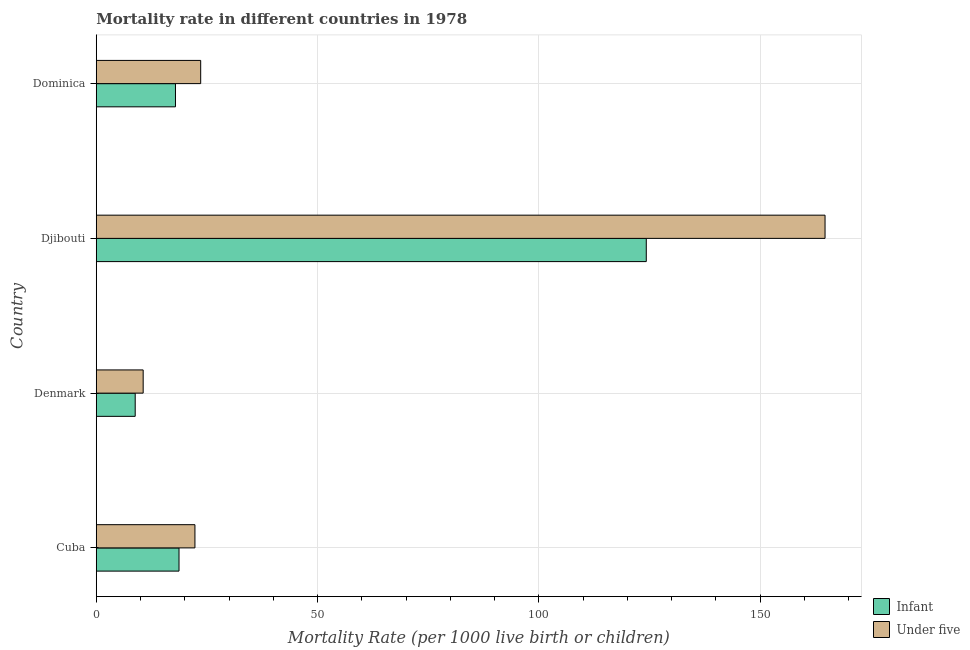Are the number of bars per tick equal to the number of legend labels?
Your response must be concise. Yes. Are the number of bars on each tick of the Y-axis equal?
Your response must be concise. Yes. How many bars are there on the 2nd tick from the top?
Provide a short and direct response. 2. What is the label of the 3rd group of bars from the top?
Offer a terse response. Denmark. What is the infant mortality rate in Denmark?
Your answer should be compact. 8.8. Across all countries, what is the maximum infant mortality rate?
Ensure brevity in your answer.  124.3. In which country was the under-5 mortality rate maximum?
Your response must be concise. Djibouti. In which country was the infant mortality rate minimum?
Your response must be concise. Denmark. What is the total under-5 mortality rate in the graph?
Provide a succinct answer. 221.2. What is the difference between the infant mortality rate in Denmark and that in Djibouti?
Ensure brevity in your answer.  -115.5. What is the difference between the under-5 mortality rate in Cuba and the infant mortality rate in Dominica?
Make the answer very short. 4.4. What is the average infant mortality rate per country?
Make the answer very short. 42.42. What is the difference between the under-5 mortality rate and infant mortality rate in Cuba?
Keep it short and to the point. 3.6. In how many countries, is the infant mortality rate greater than 140 ?
Ensure brevity in your answer.  0. What is the ratio of the infant mortality rate in Denmark to that in Djibouti?
Provide a short and direct response. 0.07. What is the difference between the highest and the second highest infant mortality rate?
Offer a terse response. 105.6. What is the difference between the highest and the lowest under-5 mortality rate?
Provide a short and direct response. 154.1. In how many countries, is the under-5 mortality rate greater than the average under-5 mortality rate taken over all countries?
Offer a terse response. 1. Is the sum of the under-5 mortality rate in Cuba and Dominica greater than the maximum infant mortality rate across all countries?
Give a very brief answer. No. What does the 2nd bar from the top in Cuba represents?
Offer a very short reply. Infant. What does the 2nd bar from the bottom in Djibouti represents?
Offer a very short reply. Under five. How many bars are there?
Make the answer very short. 8. How many countries are there in the graph?
Provide a short and direct response. 4. Are the values on the major ticks of X-axis written in scientific E-notation?
Offer a terse response. No. Does the graph contain any zero values?
Offer a very short reply. No. Does the graph contain grids?
Your response must be concise. Yes. Where does the legend appear in the graph?
Offer a very short reply. Bottom right. How many legend labels are there?
Ensure brevity in your answer.  2. How are the legend labels stacked?
Your answer should be very brief. Vertical. What is the title of the graph?
Offer a very short reply. Mortality rate in different countries in 1978. Does "Merchandise imports" appear as one of the legend labels in the graph?
Provide a short and direct response. No. What is the label or title of the X-axis?
Keep it short and to the point. Mortality Rate (per 1000 live birth or children). What is the label or title of the Y-axis?
Keep it short and to the point. Country. What is the Mortality Rate (per 1000 live birth or children) of Under five in Cuba?
Your answer should be very brief. 22.3. What is the Mortality Rate (per 1000 live birth or children) of Infant in Djibouti?
Give a very brief answer. 124.3. What is the Mortality Rate (per 1000 live birth or children) in Under five in Djibouti?
Your answer should be very brief. 164.7. What is the Mortality Rate (per 1000 live birth or children) in Under five in Dominica?
Your answer should be compact. 23.6. Across all countries, what is the maximum Mortality Rate (per 1000 live birth or children) in Infant?
Offer a very short reply. 124.3. Across all countries, what is the maximum Mortality Rate (per 1000 live birth or children) of Under five?
Provide a succinct answer. 164.7. Across all countries, what is the minimum Mortality Rate (per 1000 live birth or children) in Infant?
Give a very brief answer. 8.8. What is the total Mortality Rate (per 1000 live birth or children) in Infant in the graph?
Your answer should be compact. 169.7. What is the total Mortality Rate (per 1000 live birth or children) in Under five in the graph?
Your answer should be very brief. 221.2. What is the difference between the Mortality Rate (per 1000 live birth or children) in Infant in Cuba and that in Denmark?
Give a very brief answer. 9.9. What is the difference between the Mortality Rate (per 1000 live birth or children) of Infant in Cuba and that in Djibouti?
Give a very brief answer. -105.6. What is the difference between the Mortality Rate (per 1000 live birth or children) in Under five in Cuba and that in Djibouti?
Provide a succinct answer. -142.4. What is the difference between the Mortality Rate (per 1000 live birth or children) in Infant in Cuba and that in Dominica?
Give a very brief answer. 0.8. What is the difference between the Mortality Rate (per 1000 live birth or children) of Under five in Cuba and that in Dominica?
Offer a terse response. -1.3. What is the difference between the Mortality Rate (per 1000 live birth or children) of Infant in Denmark and that in Djibouti?
Keep it short and to the point. -115.5. What is the difference between the Mortality Rate (per 1000 live birth or children) in Under five in Denmark and that in Djibouti?
Provide a succinct answer. -154.1. What is the difference between the Mortality Rate (per 1000 live birth or children) of Infant in Denmark and that in Dominica?
Make the answer very short. -9.1. What is the difference between the Mortality Rate (per 1000 live birth or children) in Infant in Djibouti and that in Dominica?
Your answer should be compact. 106.4. What is the difference between the Mortality Rate (per 1000 live birth or children) in Under five in Djibouti and that in Dominica?
Make the answer very short. 141.1. What is the difference between the Mortality Rate (per 1000 live birth or children) of Infant in Cuba and the Mortality Rate (per 1000 live birth or children) of Under five in Djibouti?
Offer a terse response. -146. What is the difference between the Mortality Rate (per 1000 live birth or children) of Infant in Denmark and the Mortality Rate (per 1000 live birth or children) of Under five in Djibouti?
Keep it short and to the point. -155.9. What is the difference between the Mortality Rate (per 1000 live birth or children) of Infant in Denmark and the Mortality Rate (per 1000 live birth or children) of Under five in Dominica?
Ensure brevity in your answer.  -14.8. What is the difference between the Mortality Rate (per 1000 live birth or children) in Infant in Djibouti and the Mortality Rate (per 1000 live birth or children) in Under five in Dominica?
Keep it short and to the point. 100.7. What is the average Mortality Rate (per 1000 live birth or children) of Infant per country?
Provide a succinct answer. 42.42. What is the average Mortality Rate (per 1000 live birth or children) of Under five per country?
Offer a very short reply. 55.3. What is the difference between the Mortality Rate (per 1000 live birth or children) in Infant and Mortality Rate (per 1000 live birth or children) in Under five in Djibouti?
Give a very brief answer. -40.4. What is the difference between the Mortality Rate (per 1000 live birth or children) in Infant and Mortality Rate (per 1000 live birth or children) in Under five in Dominica?
Offer a terse response. -5.7. What is the ratio of the Mortality Rate (per 1000 live birth or children) in Infant in Cuba to that in Denmark?
Offer a terse response. 2.12. What is the ratio of the Mortality Rate (per 1000 live birth or children) in Under five in Cuba to that in Denmark?
Give a very brief answer. 2.1. What is the ratio of the Mortality Rate (per 1000 live birth or children) in Infant in Cuba to that in Djibouti?
Offer a terse response. 0.15. What is the ratio of the Mortality Rate (per 1000 live birth or children) of Under five in Cuba to that in Djibouti?
Provide a short and direct response. 0.14. What is the ratio of the Mortality Rate (per 1000 live birth or children) of Infant in Cuba to that in Dominica?
Provide a short and direct response. 1.04. What is the ratio of the Mortality Rate (per 1000 live birth or children) in Under five in Cuba to that in Dominica?
Give a very brief answer. 0.94. What is the ratio of the Mortality Rate (per 1000 live birth or children) in Infant in Denmark to that in Djibouti?
Your answer should be compact. 0.07. What is the ratio of the Mortality Rate (per 1000 live birth or children) in Under five in Denmark to that in Djibouti?
Your response must be concise. 0.06. What is the ratio of the Mortality Rate (per 1000 live birth or children) in Infant in Denmark to that in Dominica?
Give a very brief answer. 0.49. What is the ratio of the Mortality Rate (per 1000 live birth or children) in Under five in Denmark to that in Dominica?
Provide a succinct answer. 0.45. What is the ratio of the Mortality Rate (per 1000 live birth or children) of Infant in Djibouti to that in Dominica?
Provide a short and direct response. 6.94. What is the ratio of the Mortality Rate (per 1000 live birth or children) of Under five in Djibouti to that in Dominica?
Provide a succinct answer. 6.98. What is the difference between the highest and the second highest Mortality Rate (per 1000 live birth or children) of Infant?
Give a very brief answer. 105.6. What is the difference between the highest and the second highest Mortality Rate (per 1000 live birth or children) of Under five?
Provide a short and direct response. 141.1. What is the difference between the highest and the lowest Mortality Rate (per 1000 live birth or children) of Infant?
Make the answer very short. 115.5. What is the difference between the highest and the lowest Mortality Rate (per 1000 live birth or children) in Under five?
Give a very brief answer. 154.1. 